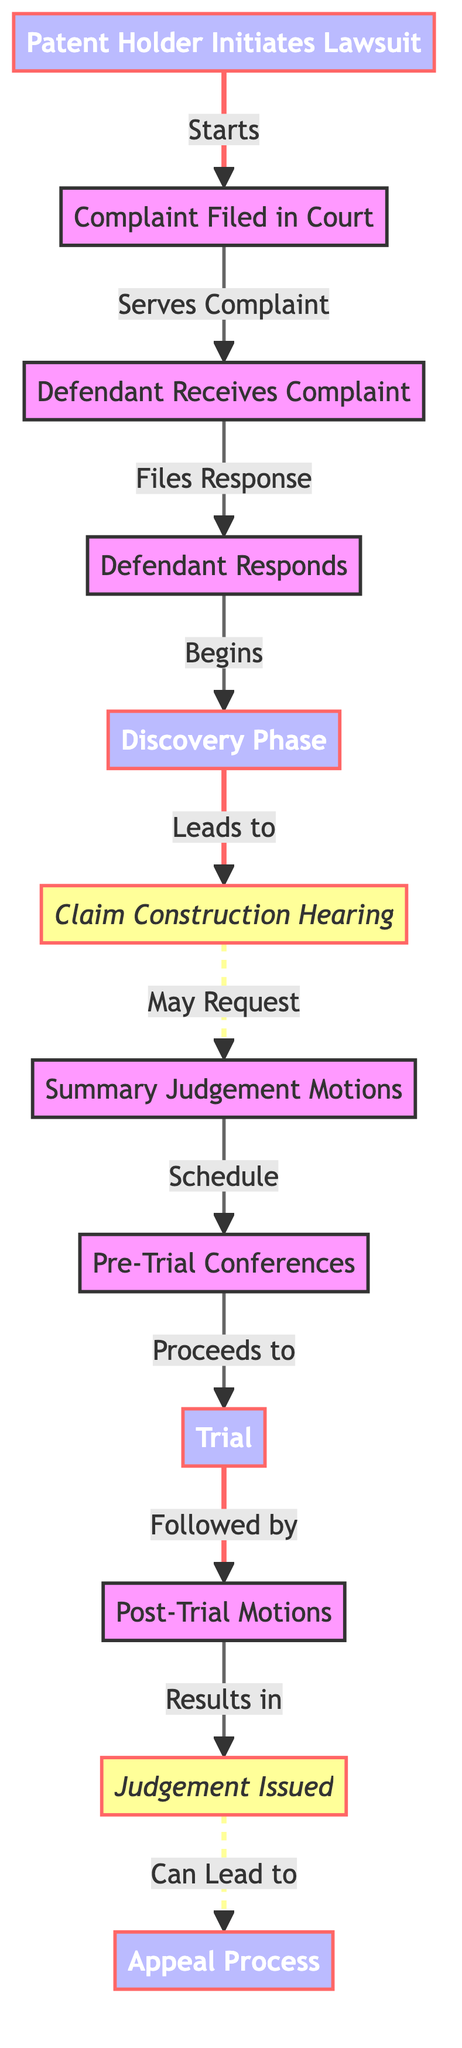What is the first step in the patent infringement litigation process? The first step in the diagram is represented by the node labeled "Patent Holder Initiates Lawsuit." This clearly indicates the starting point of the process.
Answer: Patent Holder Initiates Lawsuit What follows the "Complaint Filed in Court" step? After "Complaint Filed in Court," the next step is "Defendant Receives Complaint," as indicated by the arrows connecting these two nodes.
Answer: Defendant Receives Complaint How many main process nodes are there in the diagram? The main process nodes are "Patent Holder Initiates Lawsuit," "Discovery Phase," "Trial," and "Appeal Process." Counting these gives us a total of four main process nodes.
Answer: 4 What action occurs after the "Claim Construction Hearing"? The action that occurs after "Claim Construction Hearing" is "Summary Judgement Motions," which is directly connected to it in the diagram.
Answer: Summary Judgement Motions What is the final decision point in the diagram? The final decision point in the diagram is represented by the node labeled "Judgement Issued." This indicates the conclusion of the litigation process.
Answer: Judgement Issued What does the arrow from "Discovery Phase" to "Claim Construction Hearing" signify? The arrow signifies that the "Discovery Phase" leads directly to the "Claim Construction Hearing," indicating that the latter follows the former in the sequence of steps.
Answer: Leads to What are the two nodes connected by a dashed line? The dashed line connects "Discovery Phase" and "Post-Trial Motions." This visual style suggests some notable relationship or conditional path between these phases.
Answer: Discovery Phase and Post-Trial Motions How many total nodes are in the flowchart? Counting all nodes, including both main processes and decision points, gives us a total of twelve nodes in the flowchart.
Answer: 12 What is the relationship between "Trial" and "Post-Trial Motions"? The relationship is sequential; "Trial" is followed by "Post-Trial Motions," indicating that after the trial concludes, motions can be filed.
Answer: Followed by 